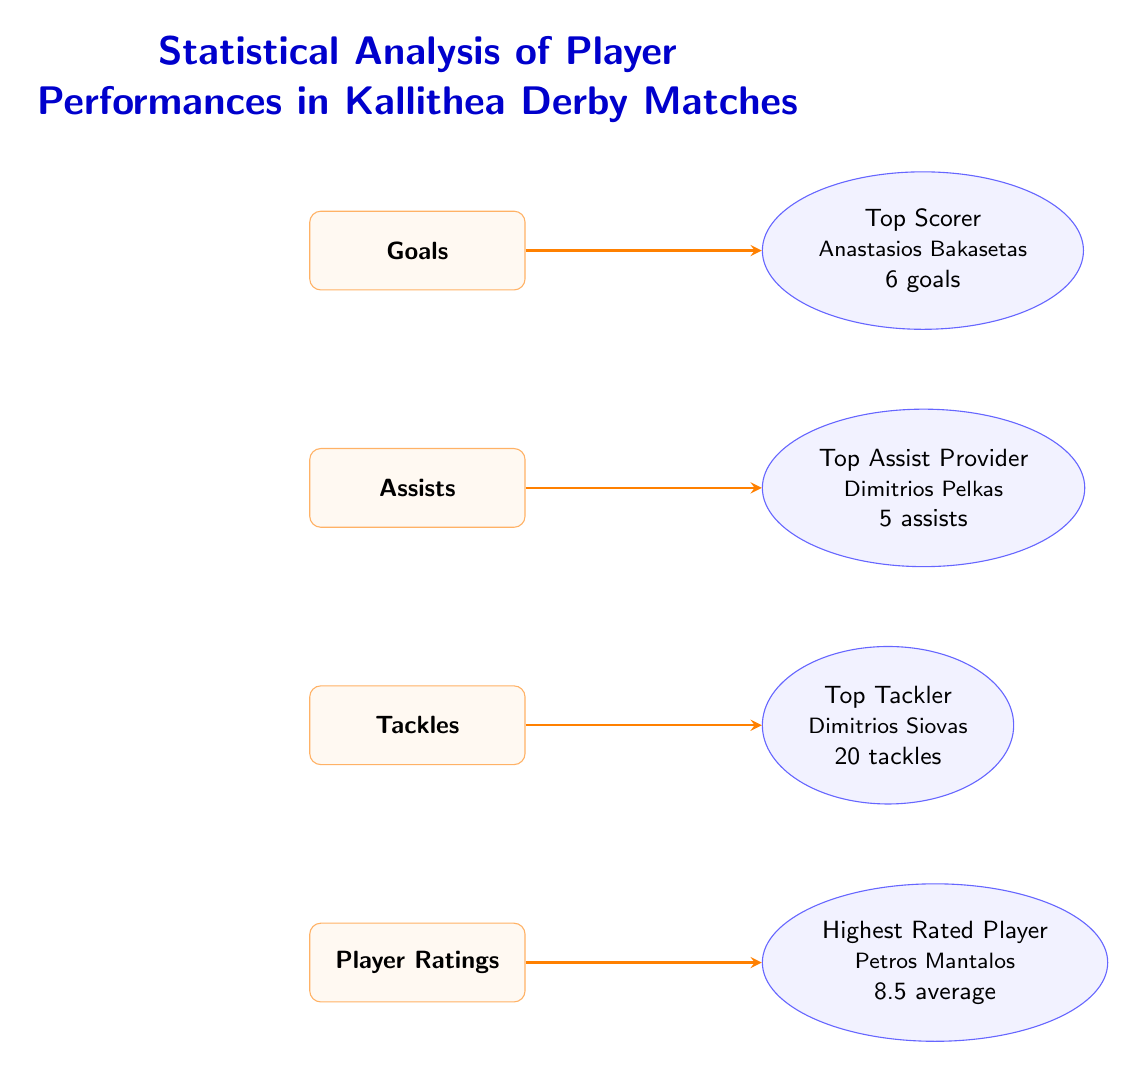What is the highest player rating in the Kallithea Derby matches? The diagram indicates that the highest rated player is Petros Mantalos, who has an average rating of 8.5.
Answer: 8.5 Who is the top scorer mentioned in the diagram? The diagram shows that the top scorer is Anastasios Bakasetas, with 6 goals.
Answer: Anastasios Bakasetas How many assists did the top assist provider record? According to the diagram, the top assist provider, Dimitrios Pelkas, recorded 5 assists.
Answer: 5 assists What is the total number of tackles made by the top tackler? The diagram specifies that the top tackler, Dimitrios Siovas, made 20 tackles.
Answer: 20 tackles Which metric is linked to the player with the highest average rating? The diagram shows that Player Ratings is linked to the highest rated player, Petros Mantalos.
Answer: Player Ratings Which player is recognized for making the most tackles? The diagram indicates that Dimitrios Siovas is recognized for being the top tackler.
Answer: Dimitrios Siovas What is the flow of connection from "Goals" in the diagram? The diagram shows that the "Goals" metric connects to the node representing the top scorer, Anastasios Bakasetas.
Answer: Top Scorer Which player has the highest number of assists? The diagram indicates that the player with the highest assists is Dimitrios Pelkas with 5 assists.
Answer: Dimitrios Pelkas Can you name one of the metrics displayed in the diagram? The diagram includes several metrics, one of which is "Tackles".
Answer: Tackles 